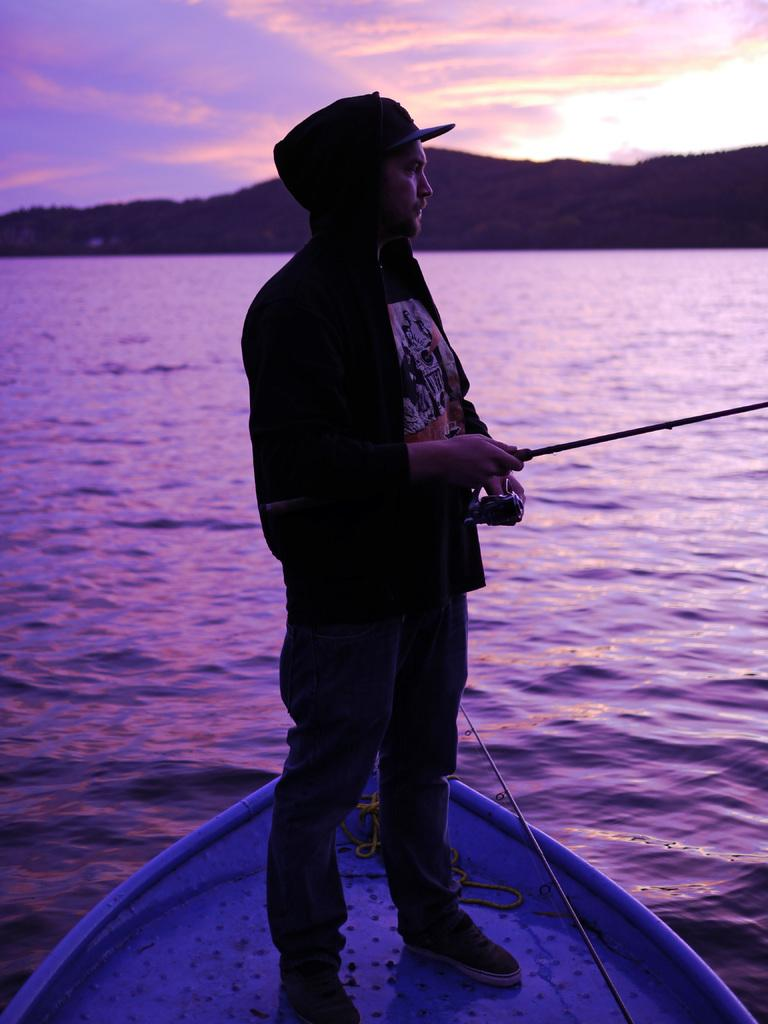What is the person in the image doing? The person is standing on a boat and fishing. What can be seen in the background of the image? There is a river, mountains, and the sky visible in the background of the image. What type of account does the person need to open in order to play chess in the image? There is no chess or account mentioned in the image; it features a person fishing on a boat. 